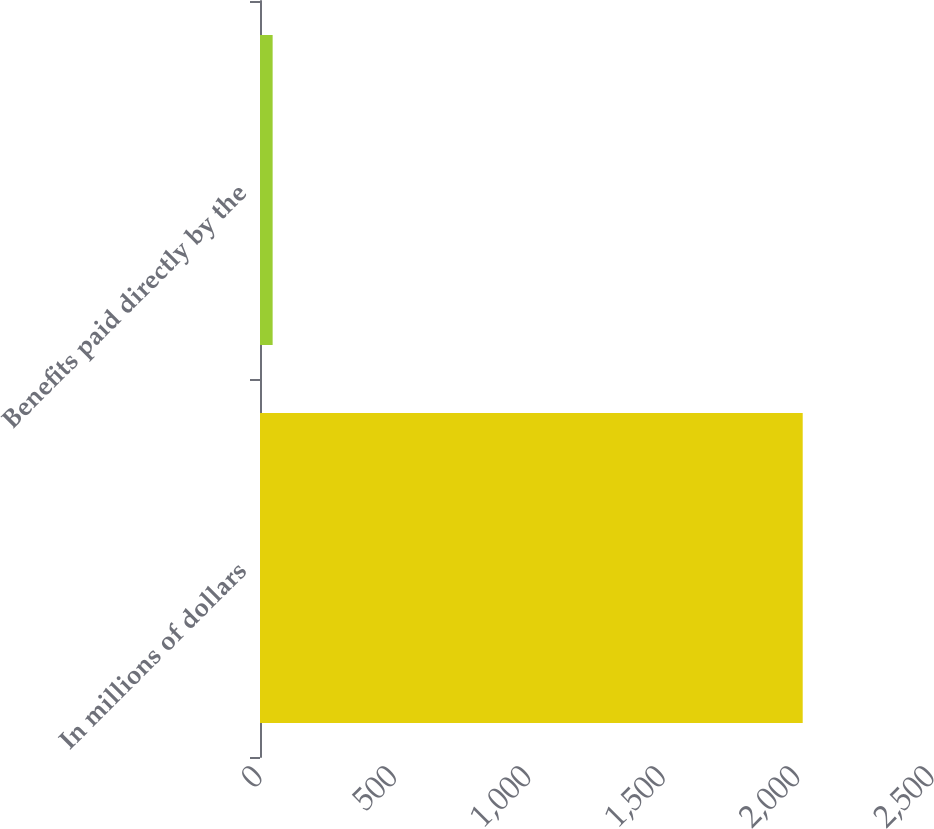<chart> <loc_0><loc_0><loc_500><loc_500><bar_chart><fcel>In millions of dollars<fcel>Benefits paid directly by the<nl><fcel>2019<fcel>47<nl></chart> 